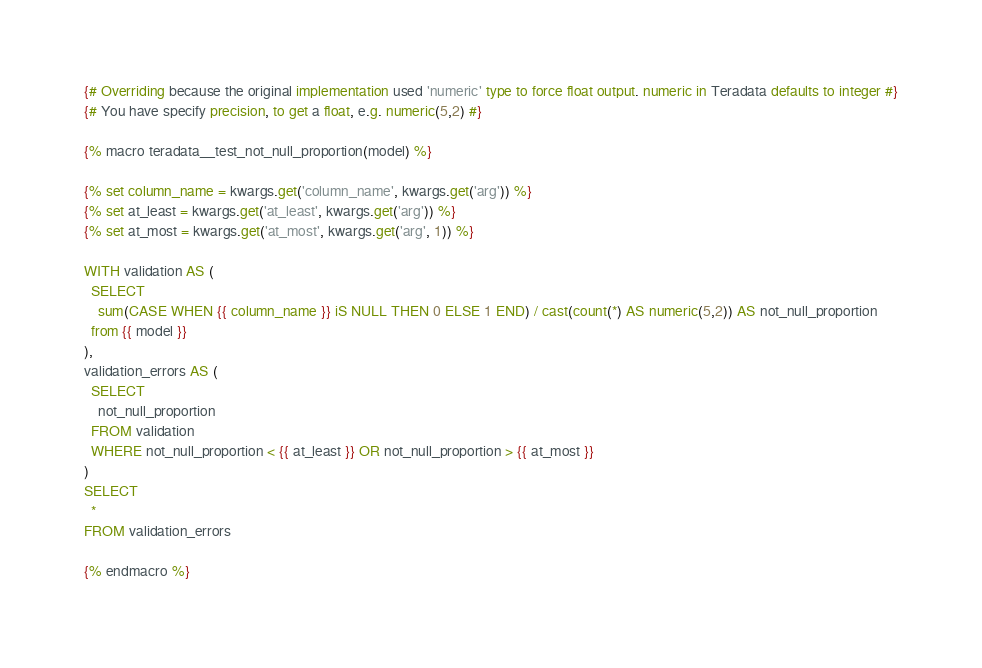Convert code to text. <code><loc_0><loc_0><loc_500><loc_500><_SQL_>{# Overriding because the original implementation used 'numeric' type to force float output. numeric in Teradata defaults to integer #}
{# You have specify precision, to get a float, e.g. numeric(5,2) #}

{% macro teradata__test_not_null_proportion(model) %}

{% set column_name = kwargs.get('column_name', kwargs.get('arg')) %}
{% set at_least = kwargs.get('at_least', kwargs.get('arg')) %}
{% set at_most = kwargs.get('at_most', kwargs.get('arg', 1)) %}

WITH validation AS (
  SELECT
    sum(CASE WHEN {{ column_name }} iS NULL THEN 0 ELSE 1 END) / cast(count(*) AS numeric(5,2)) AS not_null_proportion
  from {{ model }}
),
validation_errors AS (
  SELECT
    not_null_proportion
  FROM validation
  WHERE not_null_proportion < {{ at_least }} OR not_null_proportion > {{ at_most }}
)
SELECT
  *
FROM validation_errors

{% endmacro %}
</code> 